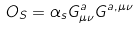<formula> <loc_0><loc_0><loc_500><loc_500>O _ { S } = \alpha _ { s } G _ { \mu \nu } ^ { a } G ^ { a , \mu \nu }</formula> 